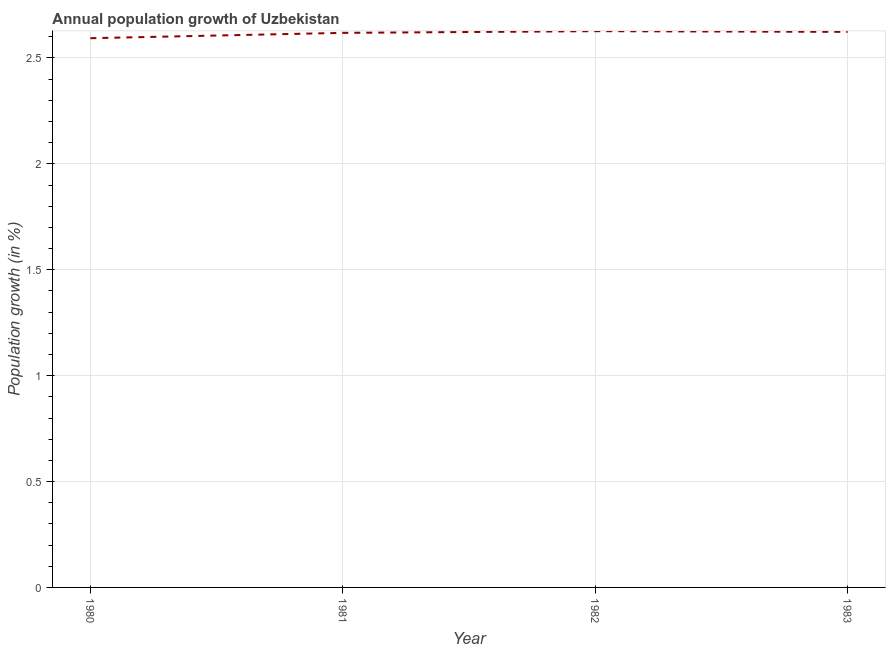What is the population growth in 1983?
Offer a very short reply. 2.62. Across all years, what is the maximum population growth?
Offer a terse response. 2.63. Across all years, what is the minimum population growth?
Provide a short and direct response. 2.59. In which year was the population growth maximum?
Offer a very short reply. 1982. What is the sum of the population growth?
Keep it short and to the point. 10.46. What is the difference between the population growth in 1981 and 1983?
Your answer should be very brief. -0. What is the average population growth per year?
Provide a succinct answer. 2.62. What is the median population growth?
Your answer should be compact. 2.62. What is the ratio of the population growth in 1980 to that in 1981?
Offer a very short reply. 0.99. What is the difference between the highest and the second highest population growth?
Offer a very short reply. 0. Is the sum of the population growth in 1981 and 1983 greater than the maximum population growth across all years?
Your answer should be very brief. Yes. What is the difference between the highest and the lowest population growth?
Keep it short and to the point. 0.03. In how many years, is the population growth greater than the average population growth taken over all years?
Give a very brief answer. 3. Does the population growth monotonically increase over the years?
Give a very brief answer. No. How many years are there in the graph?
Keep it short and to the point. 4. What is the difference between two consecutive major ticks on the Y-axis?
Ensure brevity in your answer.  0.5. Are the values on the major ticks of Y-axis written in scientific E-notation?
Provide a succinct answer. No. What is the title of the graph?
Make the answer very short. Annual population growth of Uzbekistan. What is the label or title of the X-axis?
Keep it short and to the point. Year. What is the label or title of the Y-axis?
Your response must be concise. Population growth (in %). What is the Population growth (in %) of 1980?
Provide a short and direct response. 2.59. What is the Population growth (in %) in 1981?
Provide a succinct answer. 2.62. What is the Population growth (in %) in 1982?
Your answer should be very brief. 2.63. What is the Population growth (in %) in 1983?
Provide a short and direct response. 2.62. What is the difference between the Population growth (in %) in 1980 and 1981?
Your answer should be compact. -0.03. What is the difference between the Population growth (in %) in 1980 and 1982?
Provide a succinct answer. -0.03. What is the difference between the Population growth (in %) in 1980 and 1983?
Provide a short and direct response. -0.03. What is the difference between the Population growth (in %) in 1981 and 1982?
Provide a succinct answer. -0.01. What is the difference between the Population growth (in %) in 1981 and 1983?
Keep it short and to the point. -0. What is the difference between the Population growth (in %) in 1982 and 1983?
Your answer should be very brief. 0. What is the ratio of the Population growth (in %) in 1980 to that in 1981?
Provide a short and direct response. 0.99. 